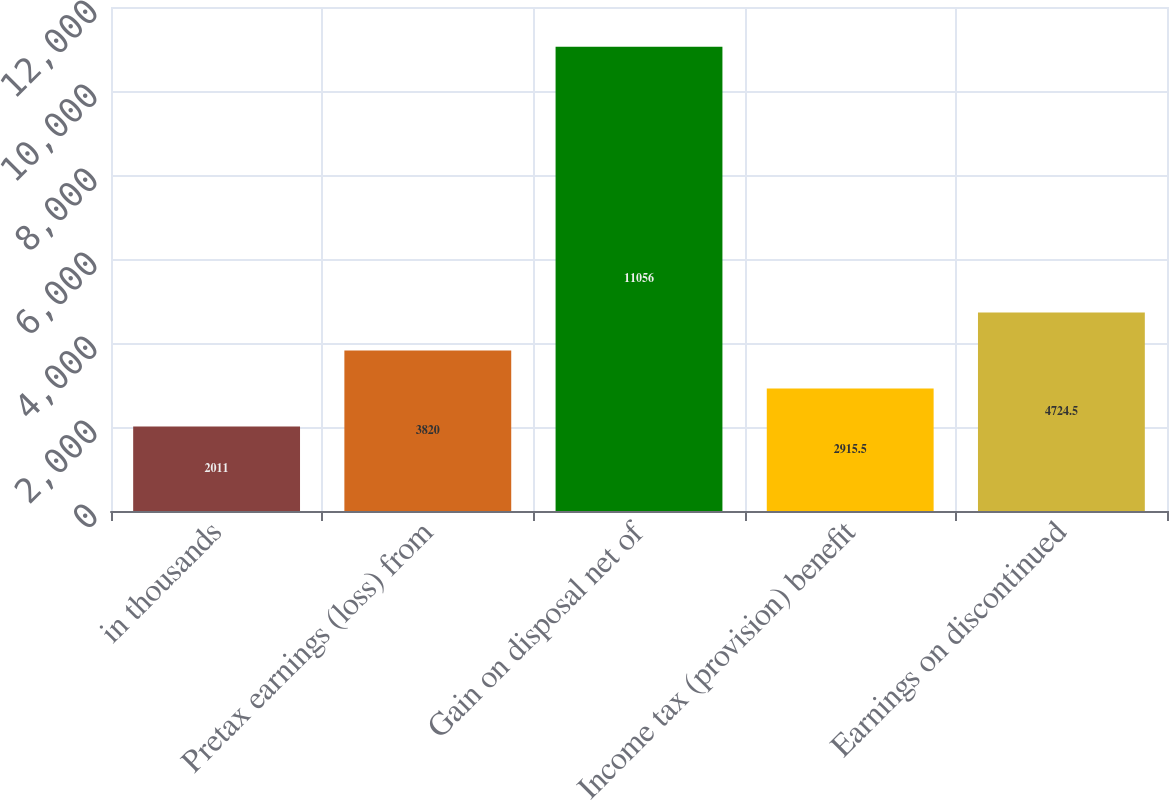Convert chart. <chart><loc_0><loc_0><loc_500><loc_500><bar_chart><fcel>in thousands<fcel>Pretax earnings (loss) from<fcel>Gain on disposal net of<fcel>Income tax (provision) benefit<fcel>Earnings on discontinued<nl><fcel>2011<fcel>3820<fcel>11056<fcel>2915.5<fcel>4724.5<nl></chart> 